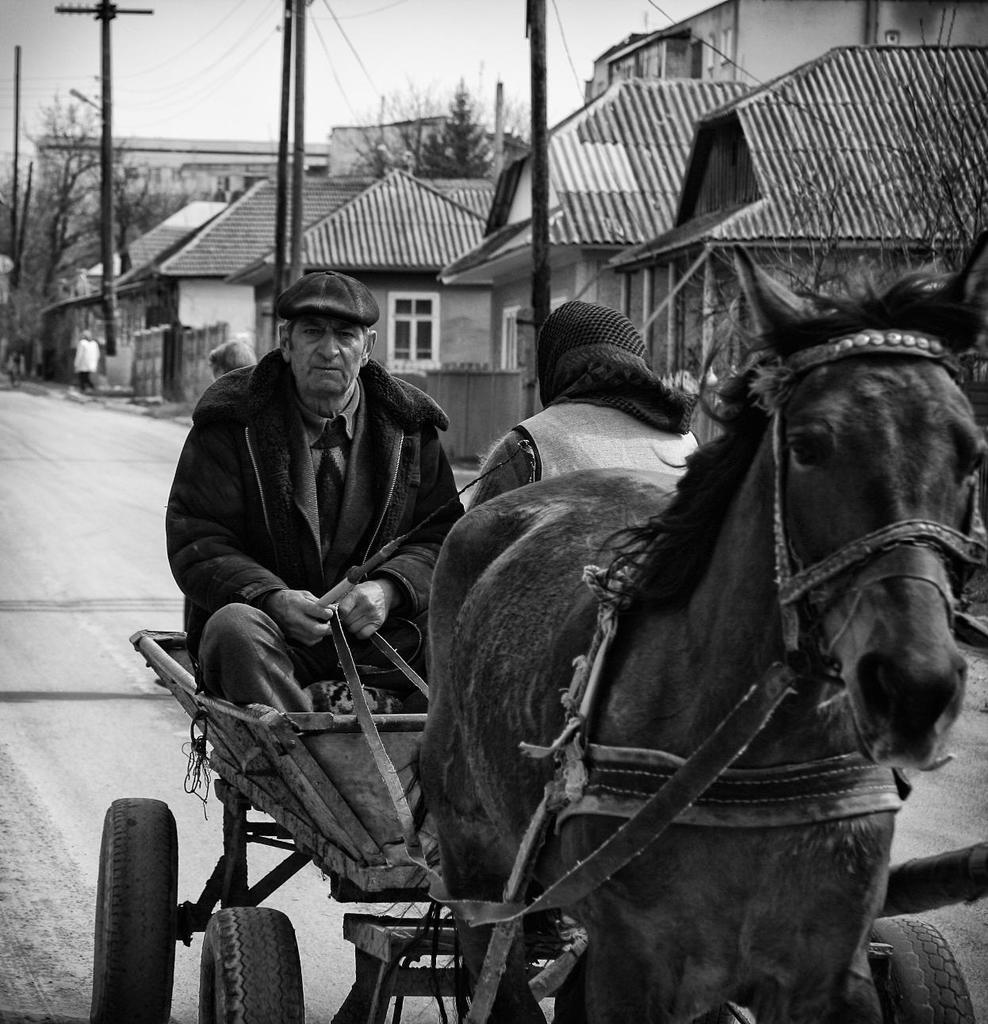What is the color scheme of the image? The image is black and white. What can be seen in the distance in the image? There are bare trees and poles in the distance. What type of structures are visible in the image? There are houses with roofs in the image. What mode of transportation is being used by the people in the image? The people are riding on a cart that is attached to a horse. What type of scale is being used to weigh the verse in the image? There is no scale or verse present in the image; it features a black and white scene with houses, trees, poles, and people riding a cart pulled by a horse. 